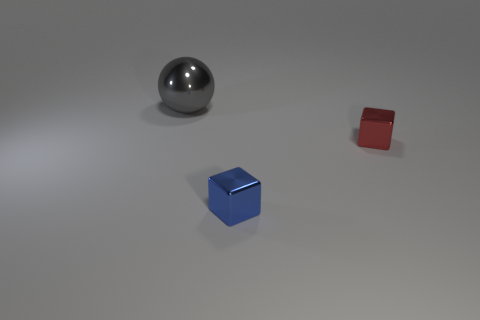What number of red objects are either shiny objects or big metallic objects?
Your response must be concise. 1. Are there more gray objects than purple balls?
Your answer should be very brief. Yes. How many things are objects that are right of the large gray object or objects in front of the big gray thing?
Ensure brevity in your answer.  2. There is a metallic block that is the same size as the red metallic thing; what color is it?
Ensure brevity in your answer.  Blue. Does the gray thing have the same material as the tiny blue object?
Your answer should be very brief. Yes. What is the small thing to the left of the shiny block behind the blue object made of?
Ensure brevity in your answer.  Metal. Is the number of small metallic blocks in front of the red shiny cube greater than the number of big red shiny spheres?
Your response must be concise. Yes. What number of other objects are there of the same size as the red metallic object?
Keep it short and to the point. 1. What color is the metal thing that is on the left side of the cube that is to the left of the tiny metallic block behind the tiny blue shiny cube?
Your answer should be compact. Gray. What number of blue shiny cubes are on the left side of the tiny object that is to the right of the block in front of the red metallic object?
Keep it short and to the point. 1. 